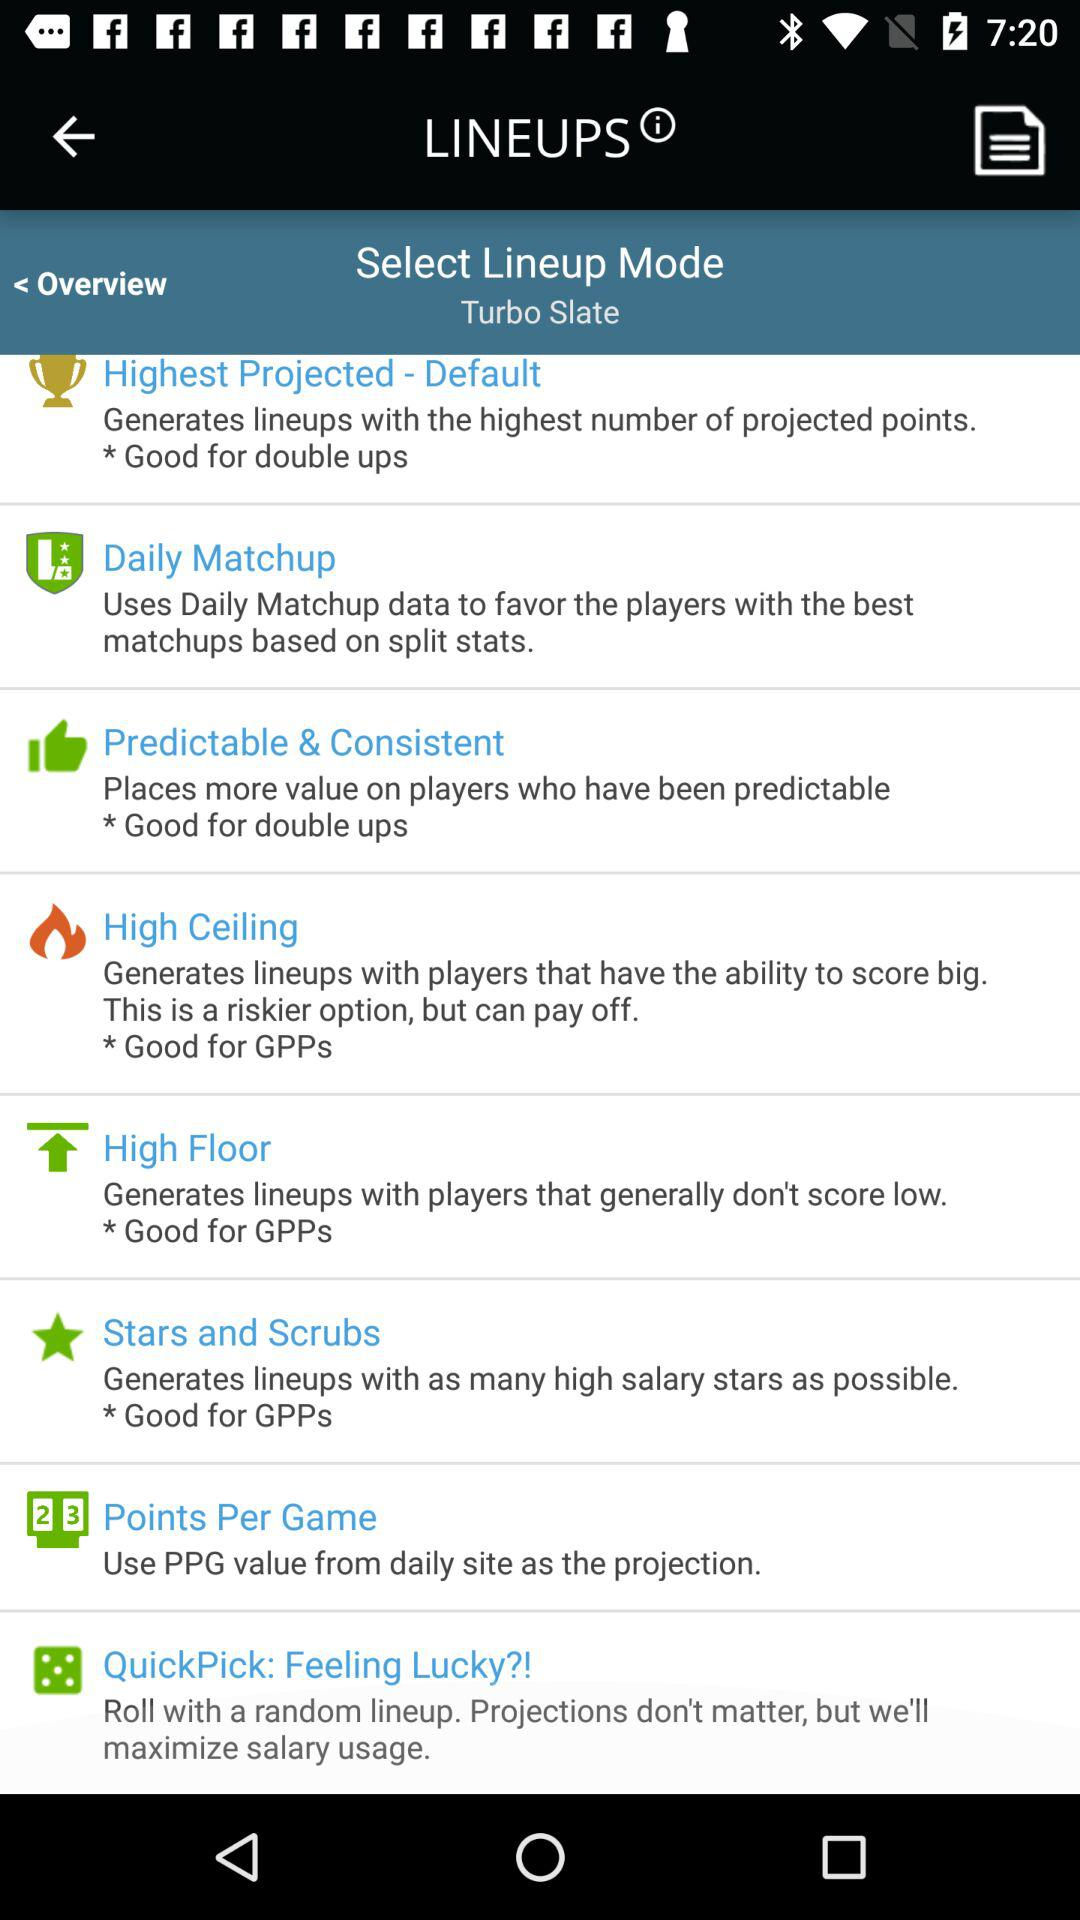What are the line-up mode options available? The options are "Highest Projected - Default", "Daily Matchup", "Predictable & Consistent", "High Ceiling", "High Floor", "Stars and Scrubs", "Points Per Game" and "QuickPick: Feeling Lucky?!". 